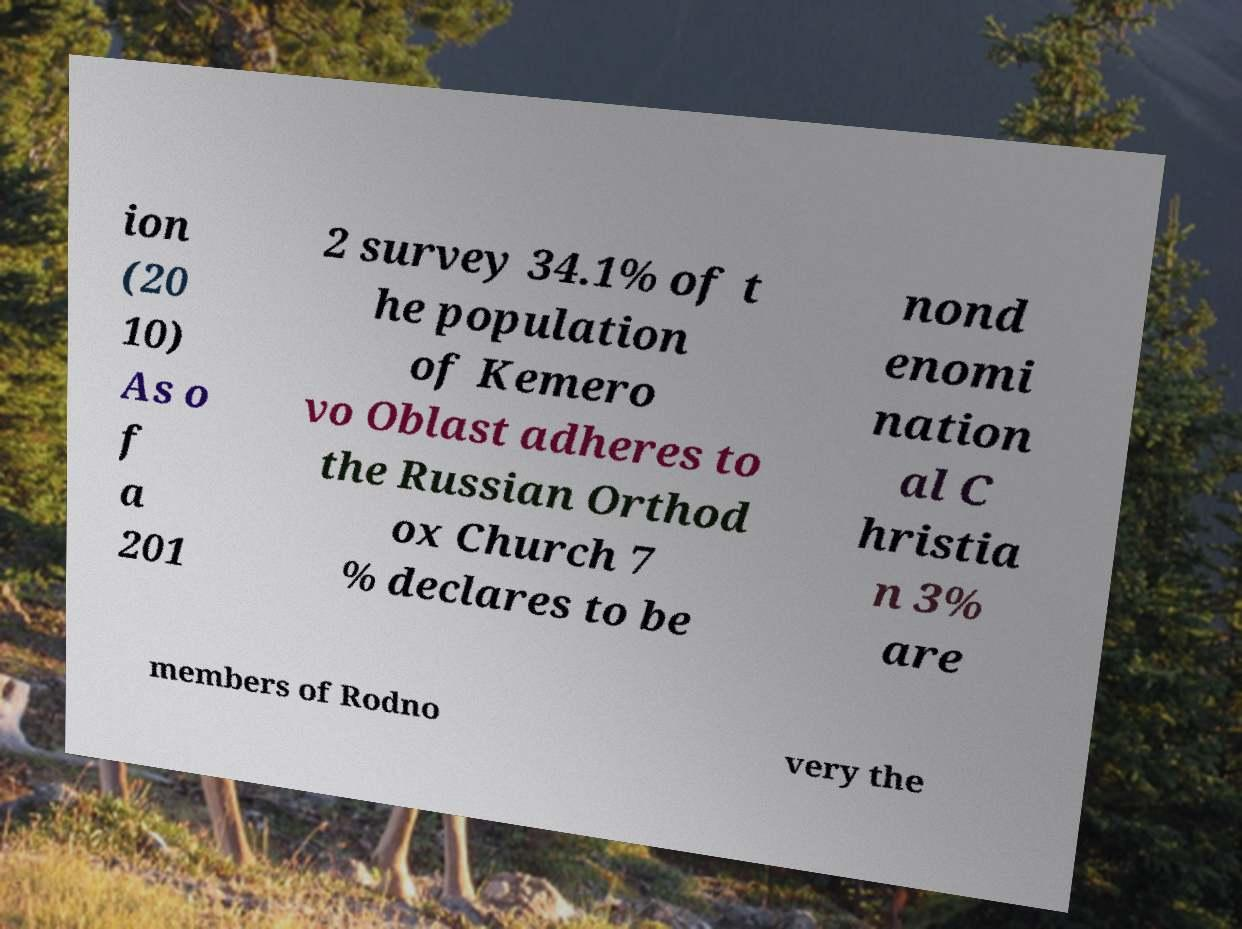Can you read and provide the text displayed in the image?This photo seems to have some interesting text. Can you extract and type it out for me? ion (20 10) As o f a 201 2 survey 34.1% of t he population of Kemero vo Oblast adheres to the Russian Orthod ox Church 7 % declares to be nond enomi nation al C hristia n 3% are members of Rodno very the 